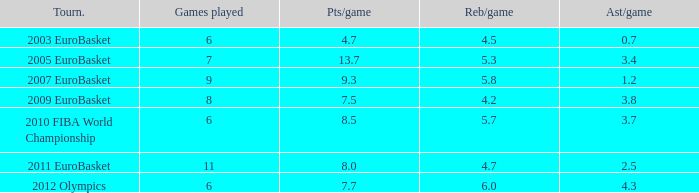How may assists per game have 7.7 points per game? 4.3. 